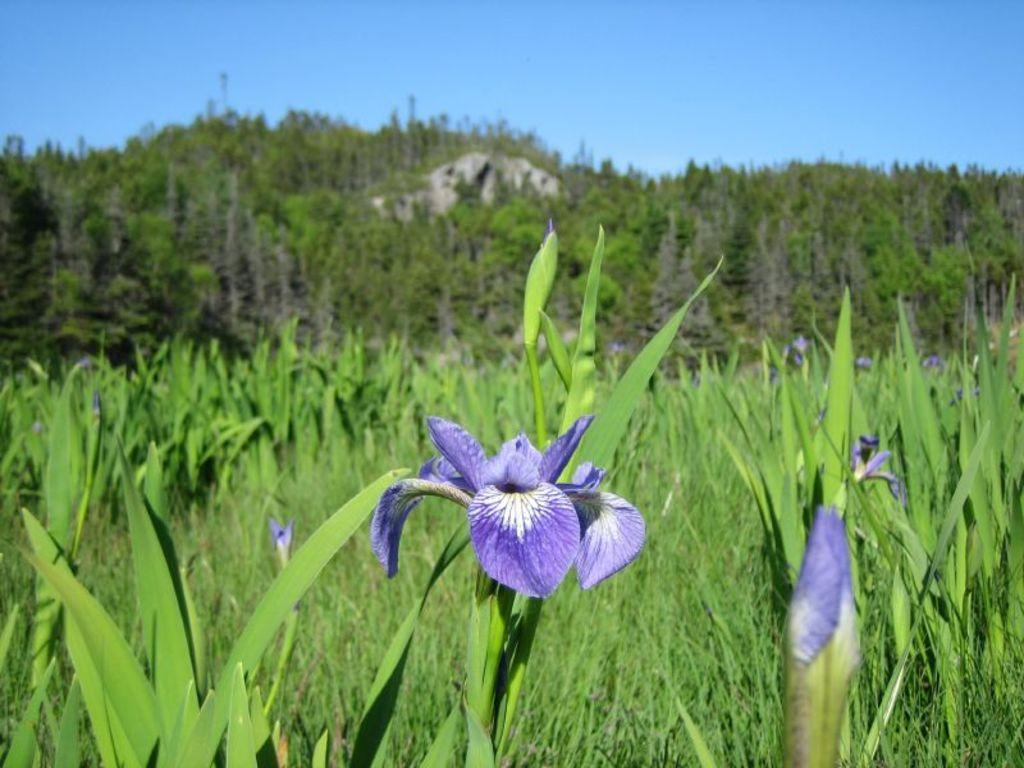What colors are the flowers in the image? The flowers in the image are white and purple. Where are the flowers located? The flowers are on plants. What can be seen in the background of the image? There are trees, a rock, and a blue sky in the background of the image. Where is the box that your mom is holding in the image? There is no box or mom present in the image; it features flowers on plants with a background of trees, a rock, and a blue sky. 